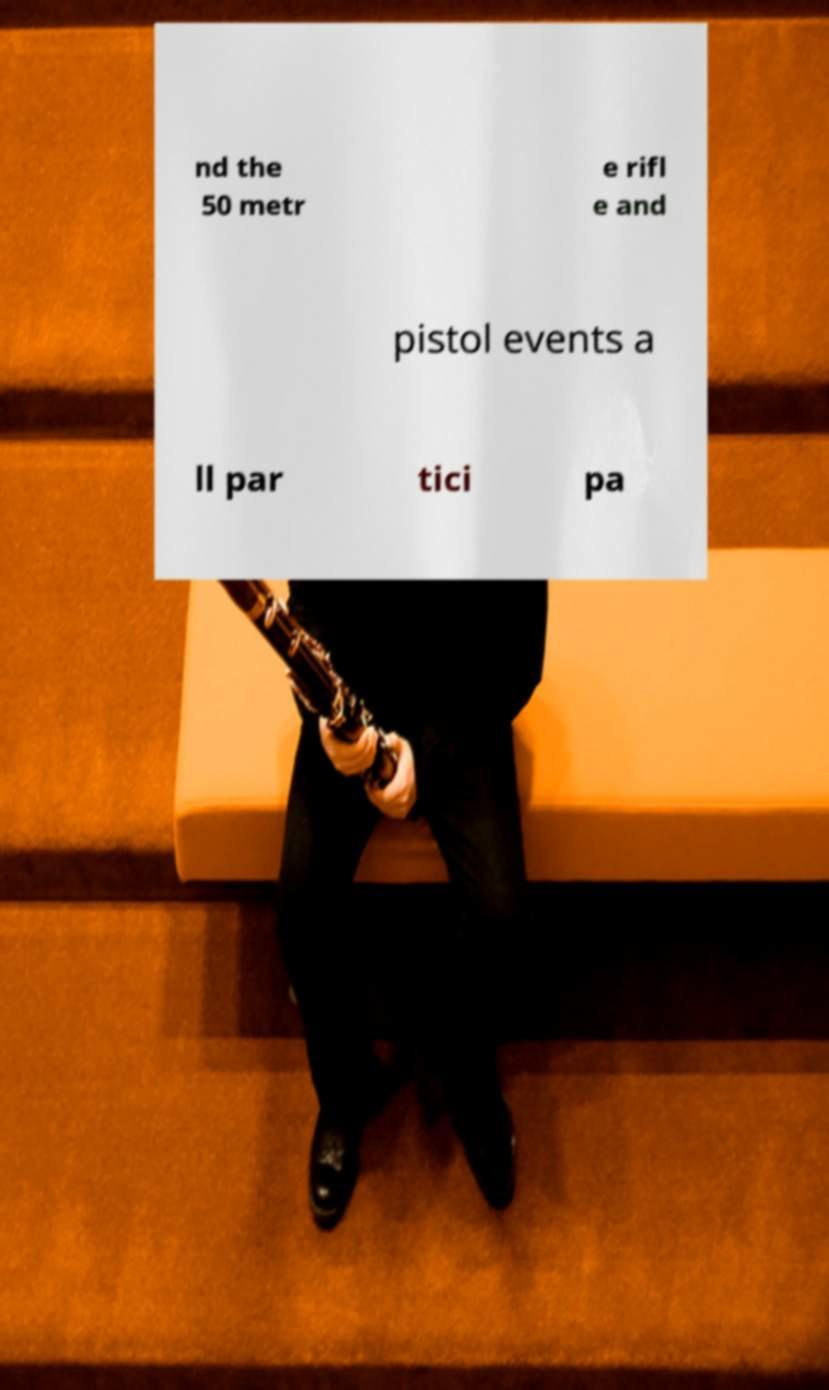There's text embedded in this image that I need extracted. Can you transcribe it verbatim? nd the 50 metr e rifl e and pistol events a ll par tici pa 